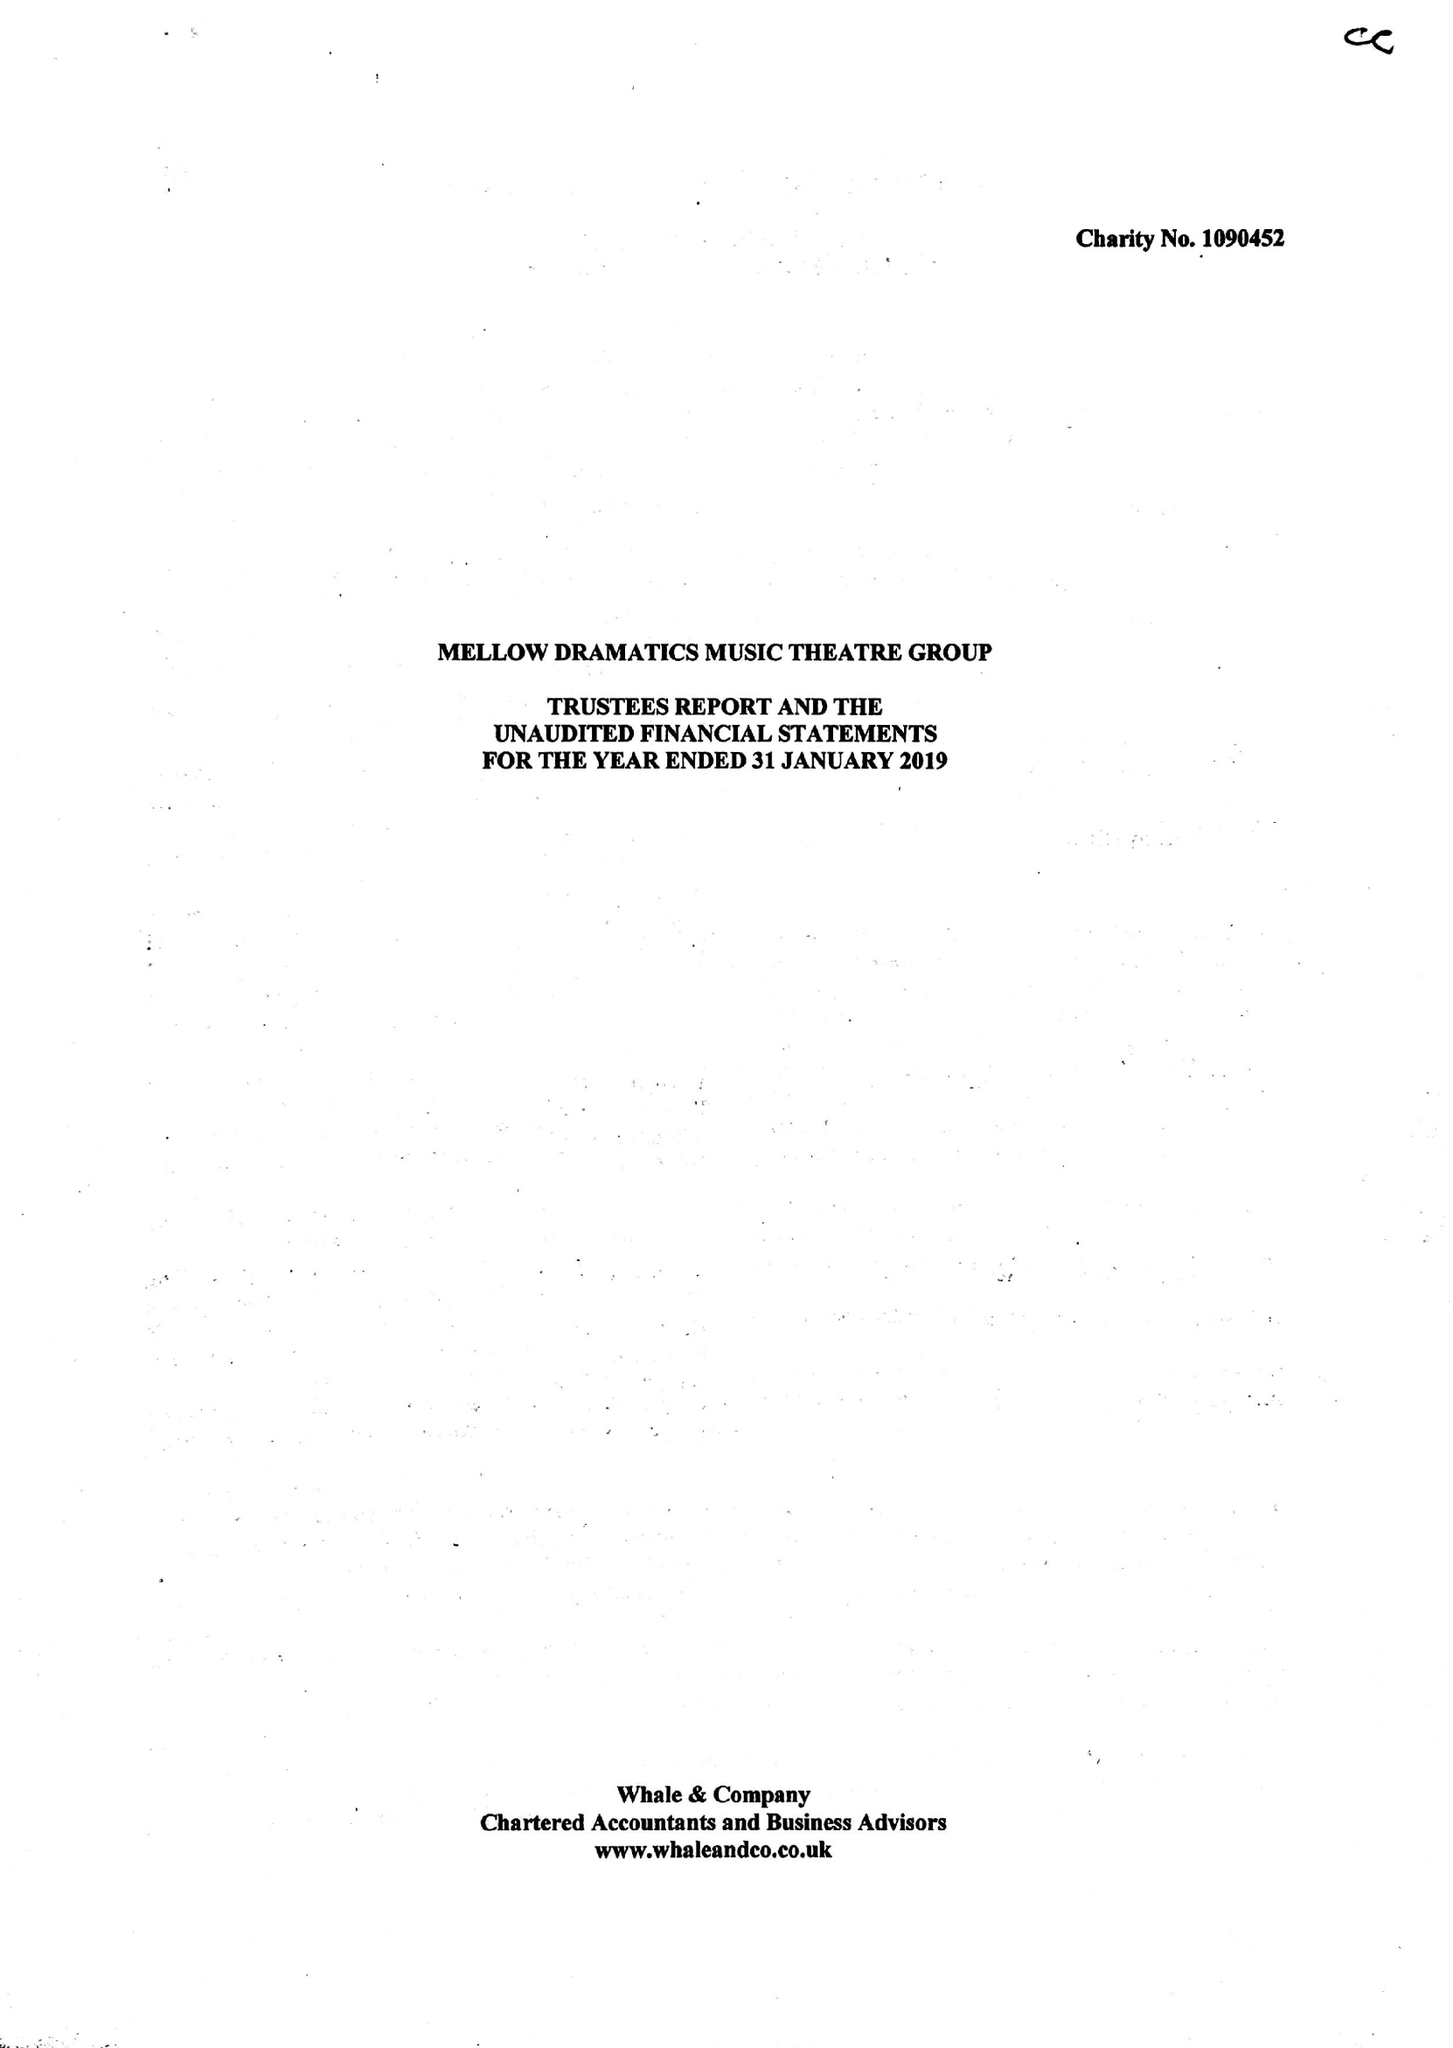What is the value for the address__post_town?
Answer the question using a single word or phrase. BURTON-ON-TRENT 